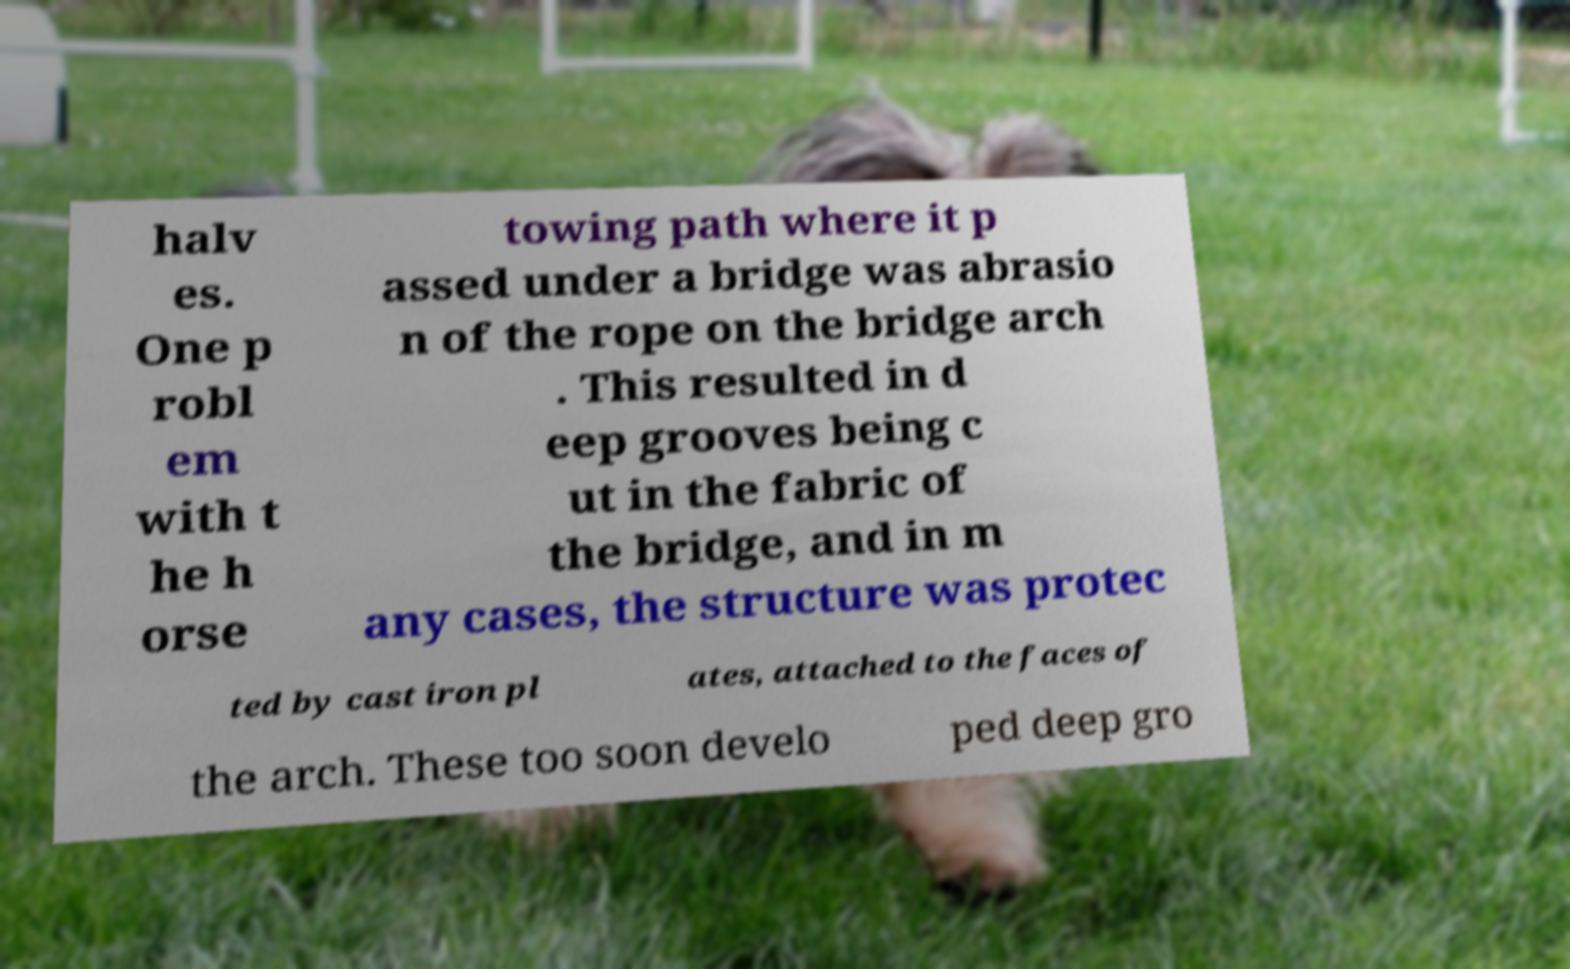Can you read and provide the text displayed in the image?This photo seems to have some interesting text. Can you extract and type it out for me? halv es. One p robl em with t he h orse towing path where it p assed under a bridge was abrasio n of the rope on the bridge arch . This resulted in d eep grooves being c ut in the fabric of the bridge, and in m any cases, the structure was protec ted by cast iron pl ates, attached to the faces of the arch. These too soon develo ped deep gro 